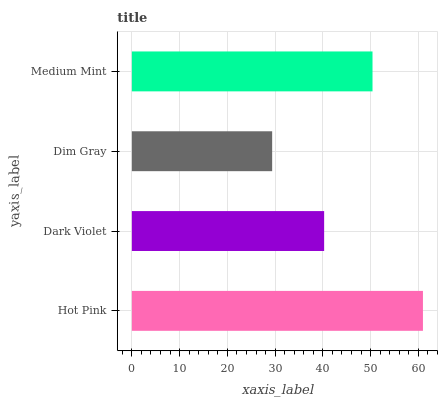Is Dim Gray the minimum?
Answer yes or no. Yes. Is Hot Pink the maximum?
Answer yes or no. Yes. Is Dark Violet the minimum?
Answer yes or no. No. Is Dark Violet the maximum?
Answer yes or no. No. Is Hot Pink greater than Dark Violet?
Answer yes or no. Yes. Is Dark Violet less than Hot Pink?
Answer yes or no. Yes. Is Dark Violet greater than Hot Pink?
Answer yes or no. No. Is Hot Pink less than Dark Violet?
Answer yes or no. No. Is Medium Mint the high median?
Answer yes or no. Yes. Is Dark Violet the low median?
Answer yes or no. Yes. Is Dim Gray the high median?
Answer yes or no. No. Is Medium Mint the low median?
Answer yes or no. No. 